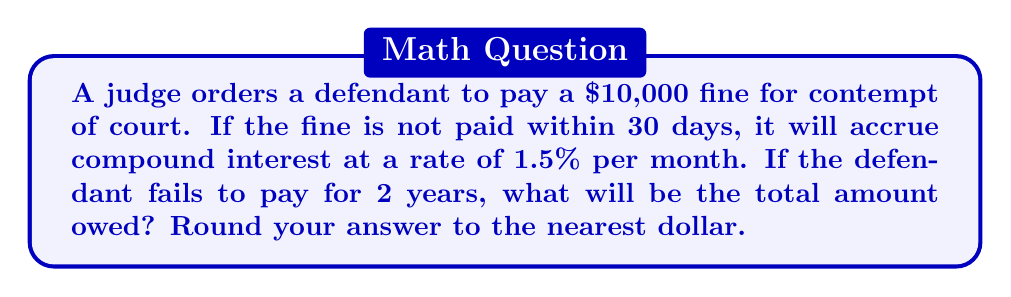Help me with this question. To solve this problem, we need to use the compound interest formula:

$$A = P(1 + r)^n$$

Where:
$A$ = Final amount
$P$ = Principal (initial amount)
$r$ = Interest rate per compounding period
$n$ = Number of compounding periods

Given:
$P = 10,000$
$r = 1.5\% = 0.015$ per month
$n = 24$ months (2 years)

Let's substitute these values into the formula:

$$A = 10,000(1 + 0.015)^{24}$$

Now we can calculate:

$$A = 10,000 \times 1.015^{24}$$
$$A = 10,000 \times 1.430798...$$
$$A = 14,307.98...$$

Rounding to the nearest dollar:

$$A ≈ 14,308$$

This calculation shows how compound interest can significantly increase the amount owed over time, which is an important consideration in judicial financial penalties.
Answer: $14,308 